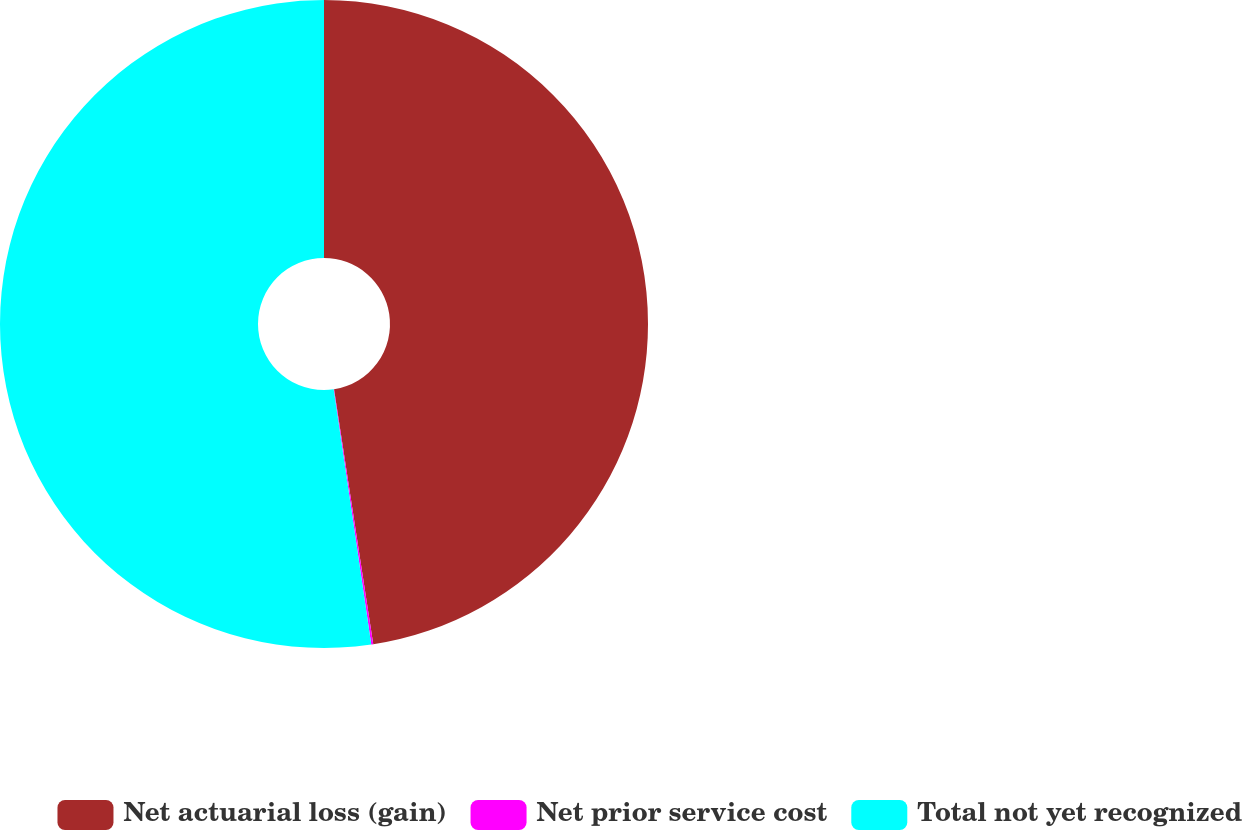Convert chart to OTSL. <chart><loc_0><loc_0><loc_500><loc_500><pie_chart><fcel>Net actuarial loss (gain)<fcel>Net prior service cost<fcel>Total not yet recognized<nl><fcel>47.57%<fcel>0.1%<fcel>52.33%<nl></chart> 